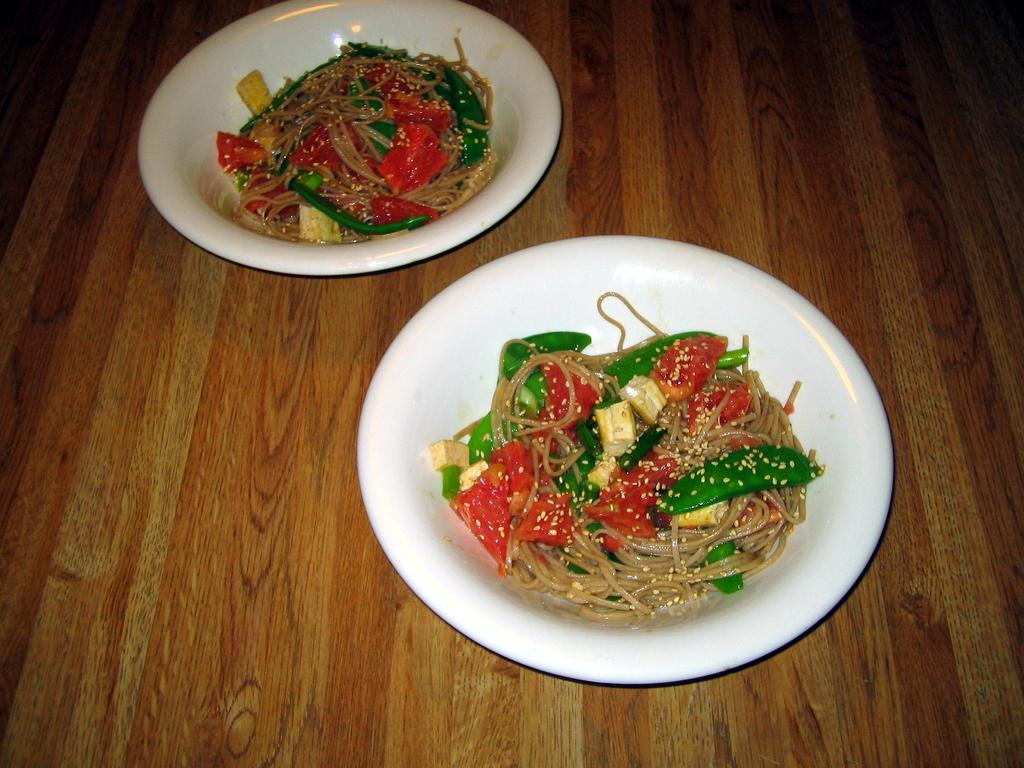How many bowls are visible in the image? There are two bowls in the image. What is inside the bowls? The bowls contain food. On what surface are the bowls placed? The bowls are placed on a wooden surface. What type of stamp can be seen on the thumb of the person in the image? There is no person or thumb present in the image, so it is not possible to determine if there is a stamp on a thumb. 